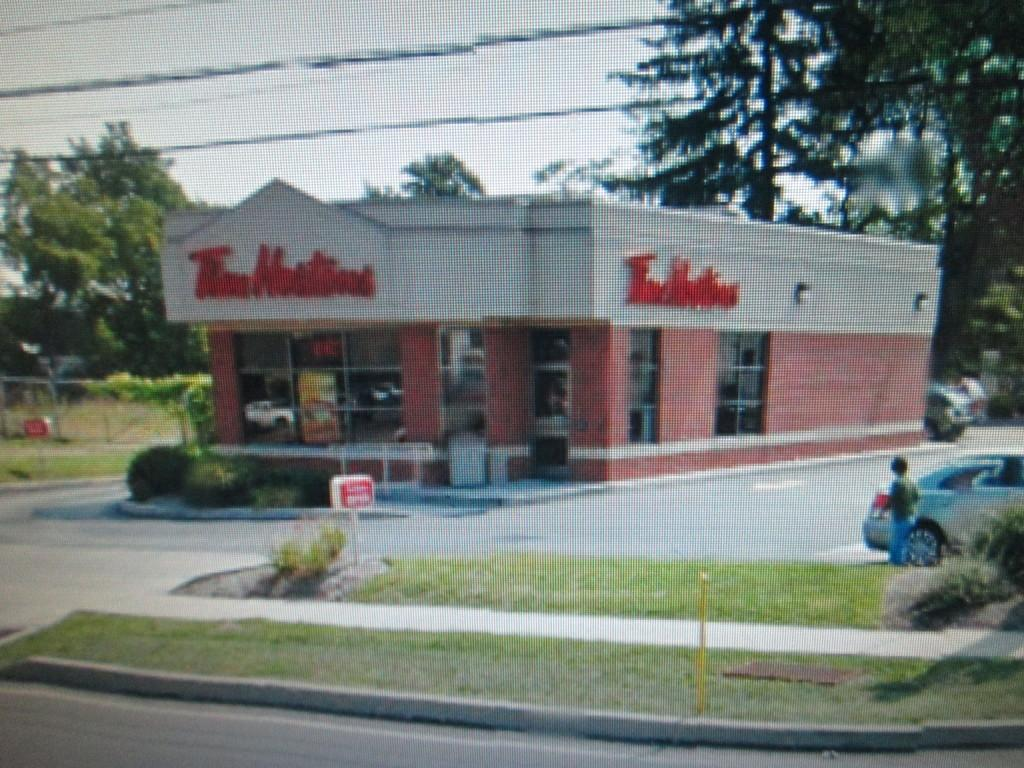What type of establishment is depicted in the image? There is a store in the image. Can you describe any text associated with the store? The store has some text. What type of natural elements can be seen in the image? There are trees and plants in the image. Are there any signs or boards with text in the image? Yes, there are boards with text in the image. What else can be seen in the image besides the store and text? There are vehicles in the image. What is visible in the background of the image? The sky is visible in the background of the image. Can you tell me how many dolls are sitting inside the cave in the image? There is no cave or dolls present in the image. 